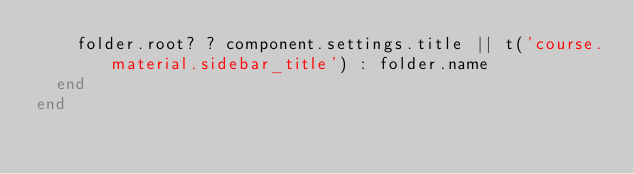Convert code to text. <code><loc_0><loc_0><loc_500><loc_500><_Ruby_>    folder.root? ? component.settings.title || t('course.material.sidebar_title') : folder.name
  end
end
</code> 